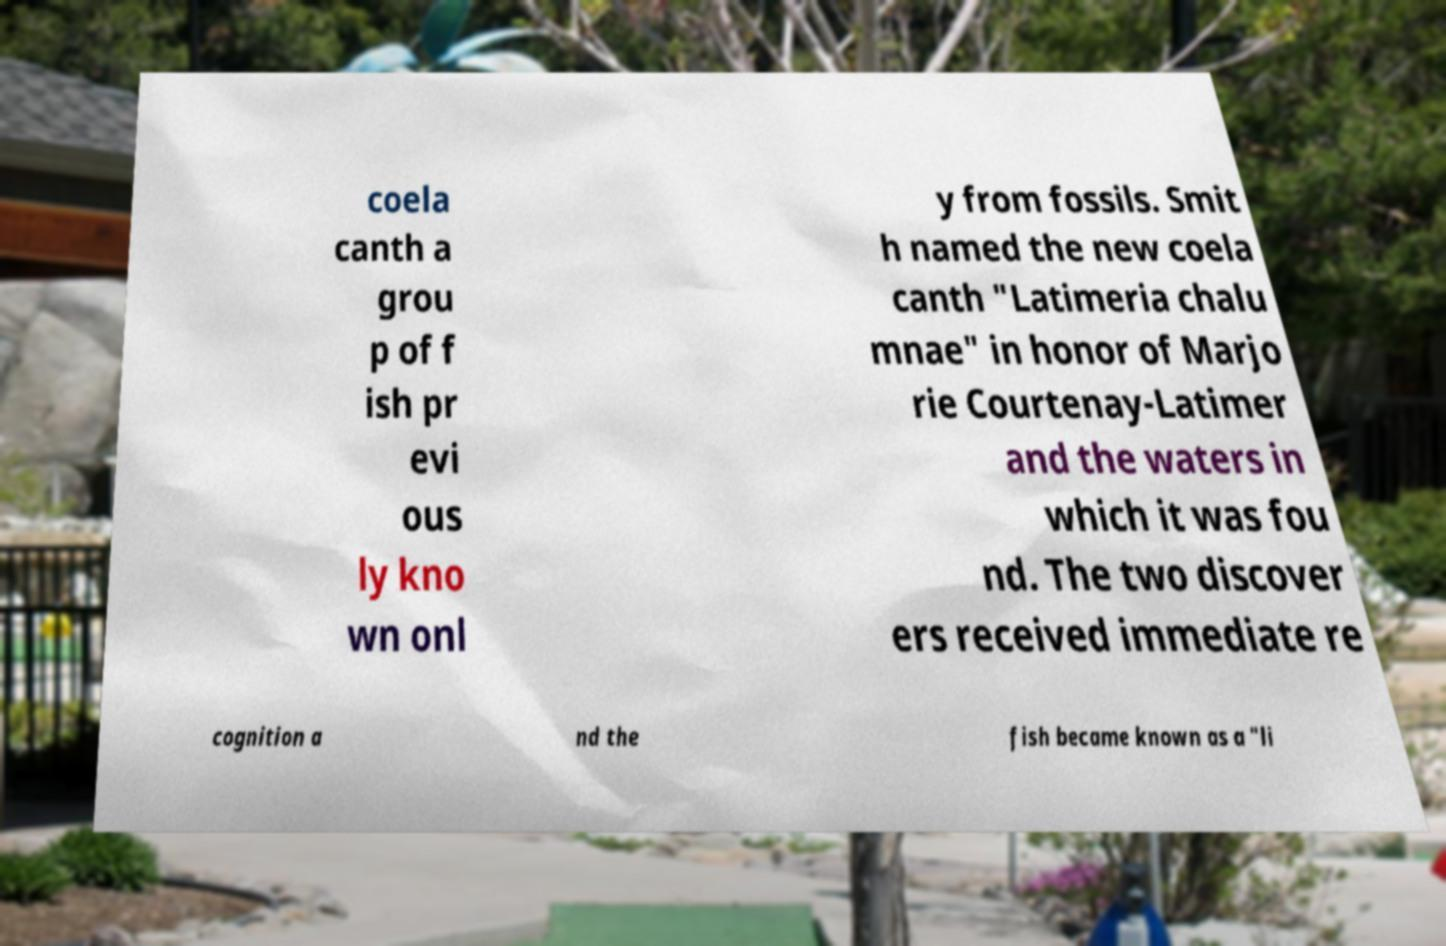Could you assist in decoding the text presented in this image and type it out clearly? coela canth a grou p of f ish pr evi ous ly kno wn onl y from fossils. Smit h named the new coela canth "Latimeria chalu mnae" in honor of Marjo rie Courtenay-Latimer and the waters in which it was fou nd. The two discover ers received immediate re cognition a nd the fish became known as a "li 